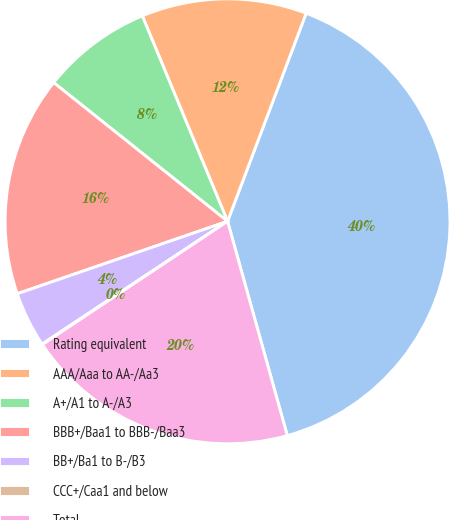<chart> <loc_0><loc_0><loc_500><loc_500><pie_chart><fcel>Rating equivalent<fcel>AAA/Aaa to AA-/Aa3<fcel>A+/A1 to A-/A3<fcel>BBB+/Baa1 to BBB-/Baa3<fcel>BB+/Ba1 to B-/B3<fcel>CCC+/Caa1 and below<fcel>Total<nl><fcel>39.93%<fcel>12.01%<fcel>8.02%<fcel>16.0%<fcel>4.03%<fcel>0.04%<fcel>19.98%<nl></chart> 